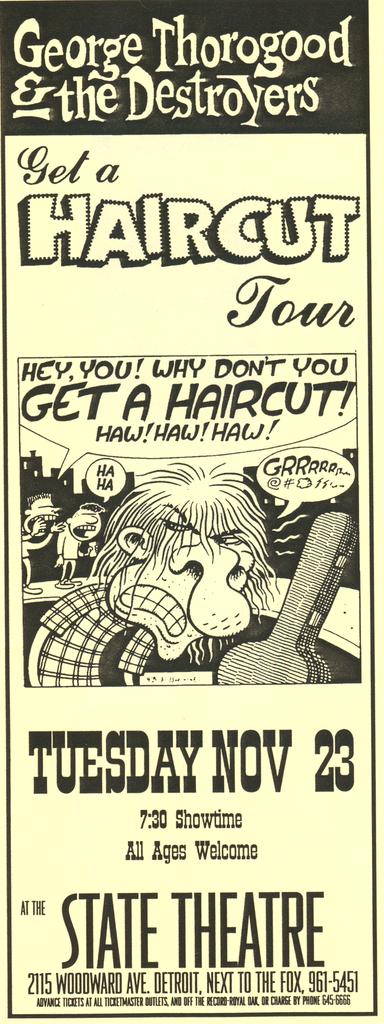What is the title of the tour listed?
Offer a very short reply. Get a haircut tour. What is the date in the image?
Your response must be concise. Tuesday nov 23. 